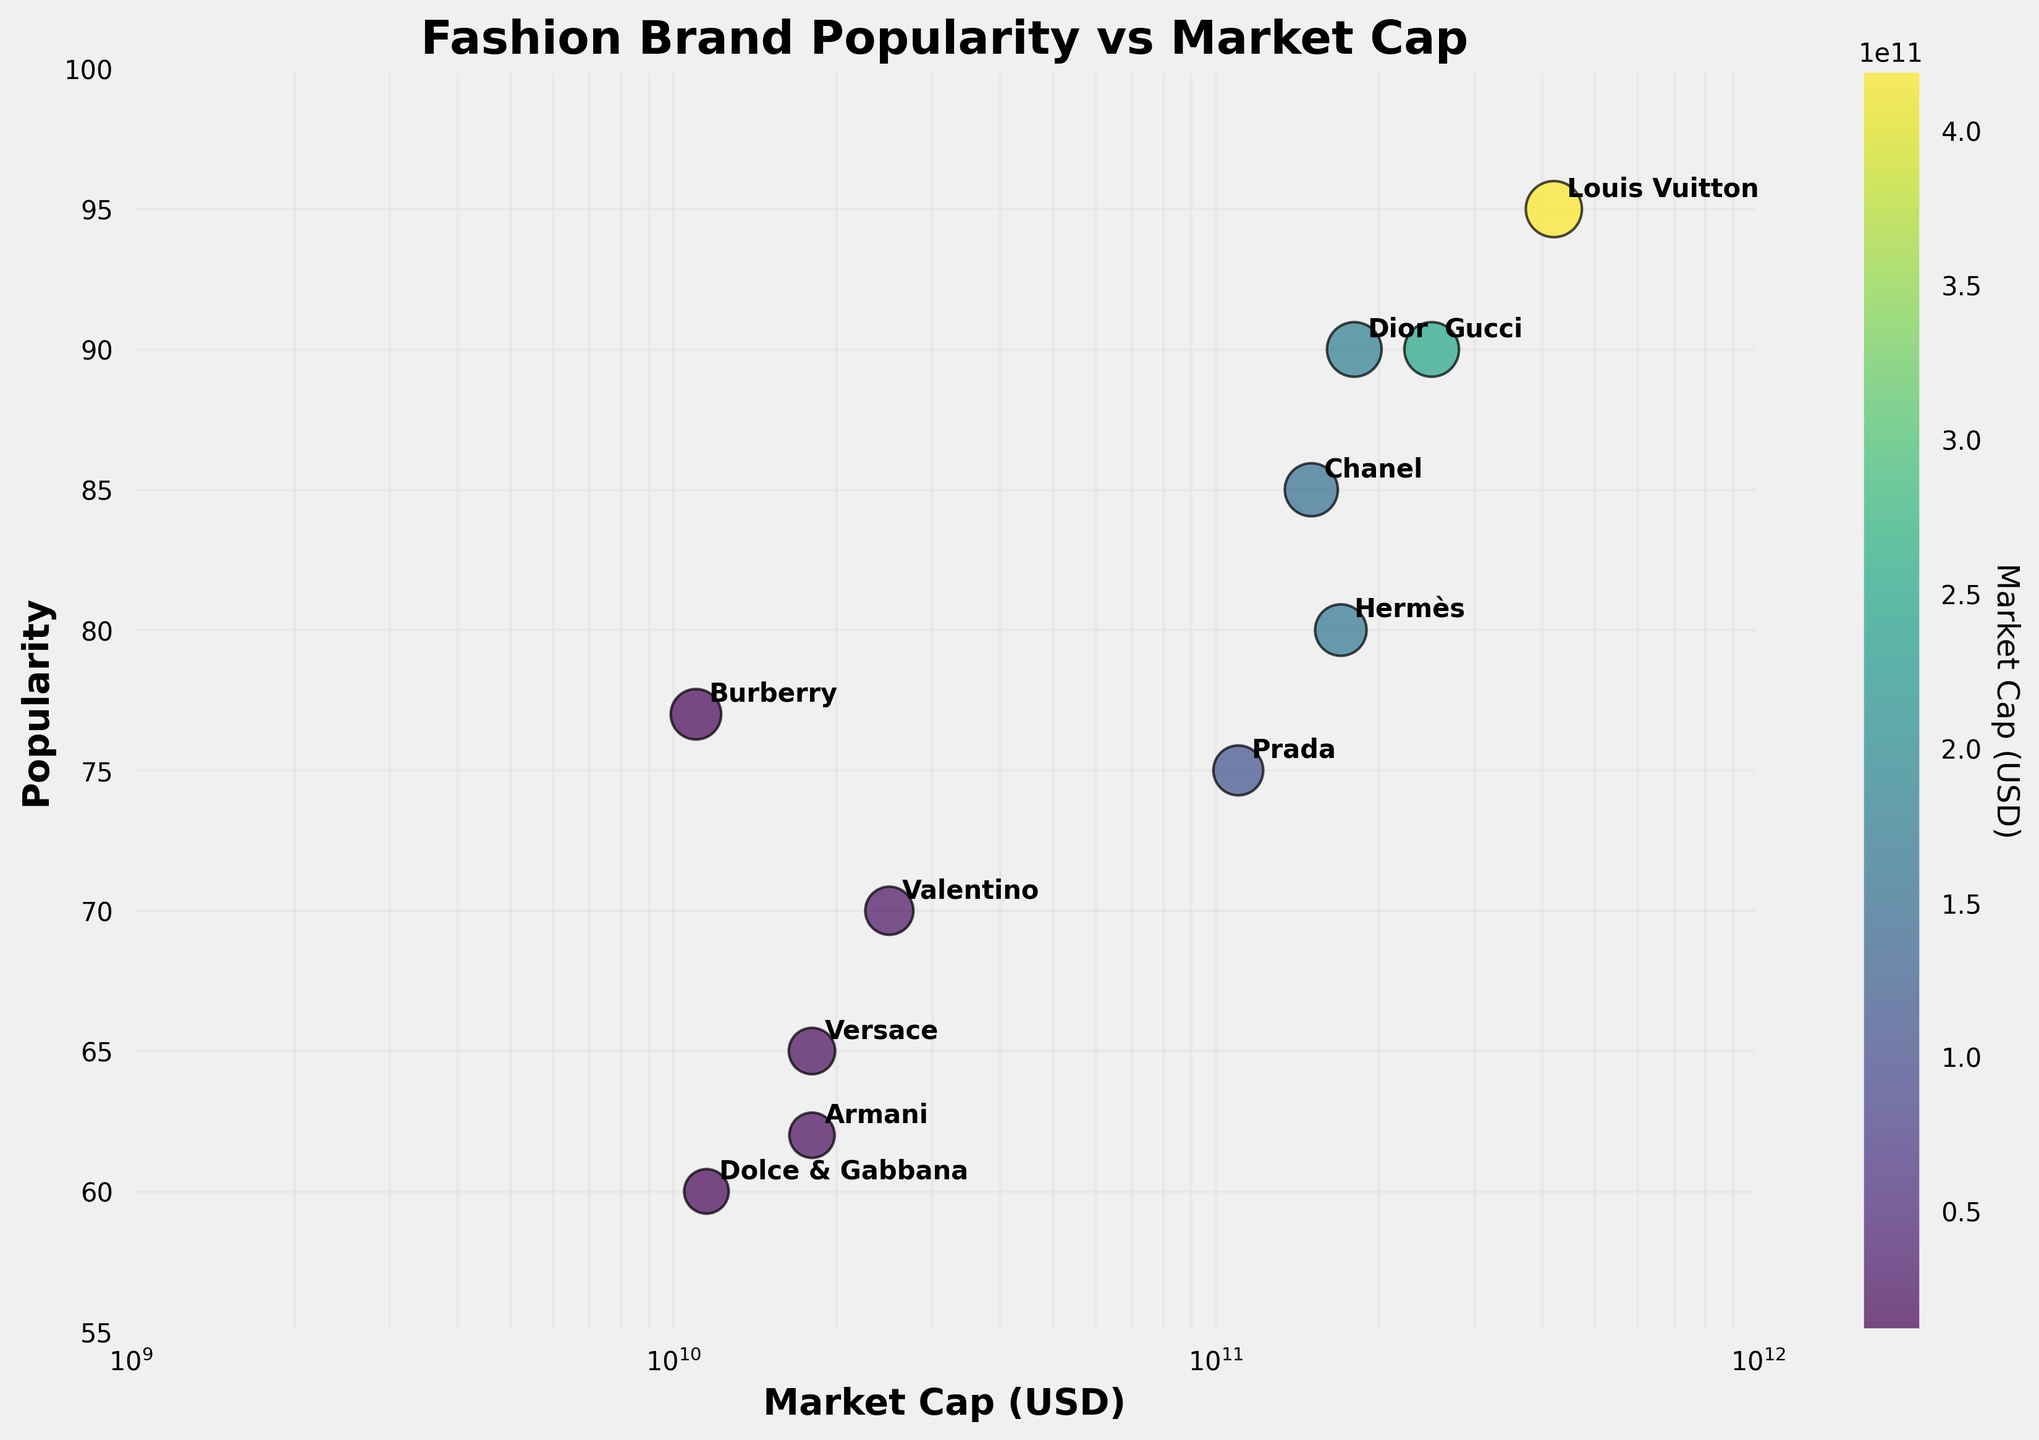What is the title of the scatter plot? The title is located at the top of the plot. It reads "Fashion Brand Popularity vs Market Cap".
Answer: Fashion Brand Popularity vs Market Cap What does the x-axis represent? The x-axis label is "Market Cap (USD)", which indicates that the axis shows the market capitalization of the brands in US dollars on a logarithmic scale.
Answer: Market Cap (USD) Which brand has the highest popularity score? By looking at the y-axis, we can identify the point that lies highest. Louis Vuitton has the highest position at a popularity score of 95.
Answer: Louis Vuitton How many brands have a popularity score lower than 70? There are points for Versace, Armani, and Dolce & Gabbana below the 70 mark on the y-axis.
Answer: 3 What is the market cap of Chanel? Chanel is labeled on the plot, and its position on the x-axis translates to around 150 billion USD.
Answer: 150 billion USD Which brand has a higher market cap: Hermès or Prada? By comparing the x-axis positions of Hermès and Prada, Hermès is to the right of Prada, indicating a higher market cap.
Answer: Hermès Calculate the average popularity of the brands with a market cap over 100 billion USD. Brands with market cap over 100 billion USD are Louis Vuitton, Gucci, Chanel, Hermès, and Prada. Their popularity scores are 95, 90, 85, 80, and 75 respectively. The average is calculated as (95 + 90 + 85 + 80 + 75) / 5 = 85.
Answer: 85 What color is used to indicate the highest market capitalization? The color bar on the right and the large value at the end help determine that the highest market cap (Louis Vuitton's) is indicated with a dark purple color.
Answer: Dark purple Which brand has the lowest market capitalization? By looking at the x-axis, the brand at the far left (smallest cap) is Burberry.
Answer: Burberry Do any brands share the same popularity score? By observing the y-axis, it’s evident that Gucci and Dior share a popularity score of 90.
Answer: Gucci and Dior 